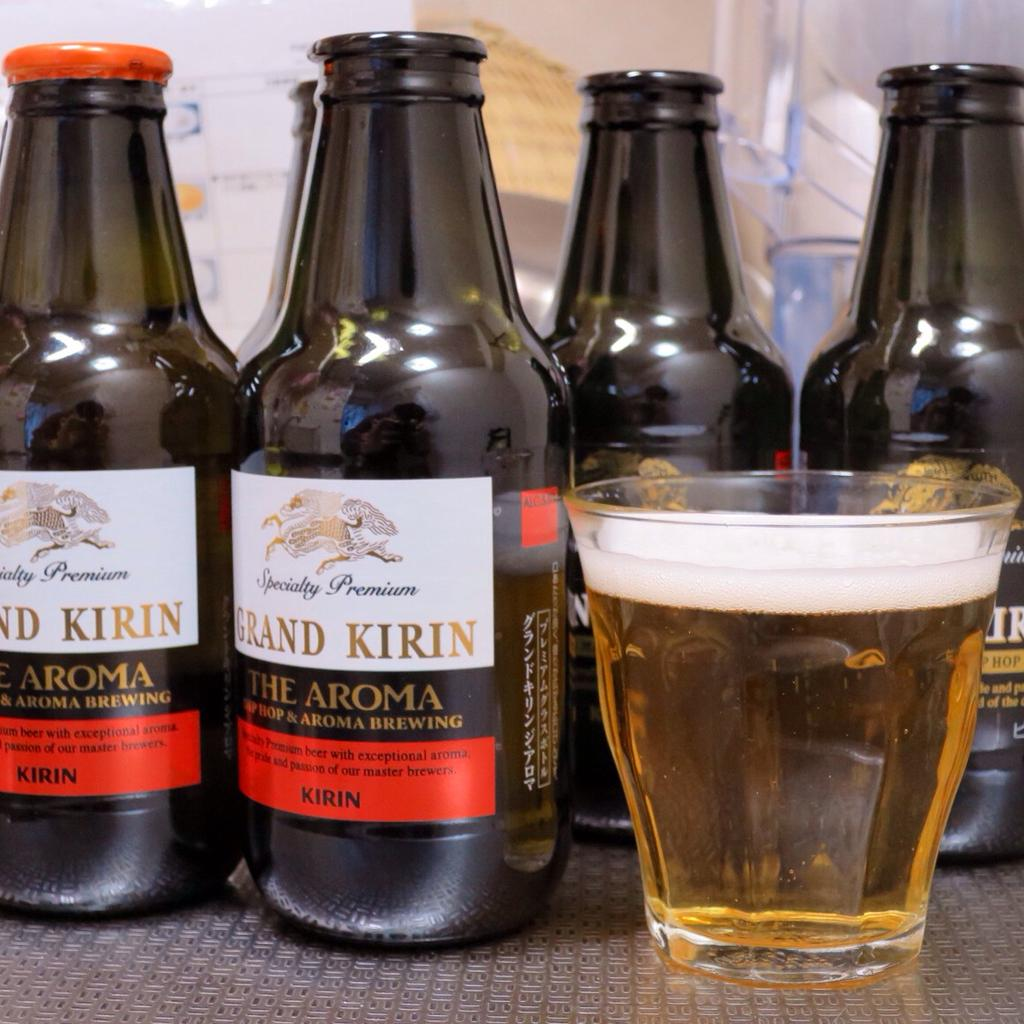<image>
Write a terse but informative summary of the picture. A dark Kirin beer with special hop and aroma with orange cap and white, gold and orange label.roma 